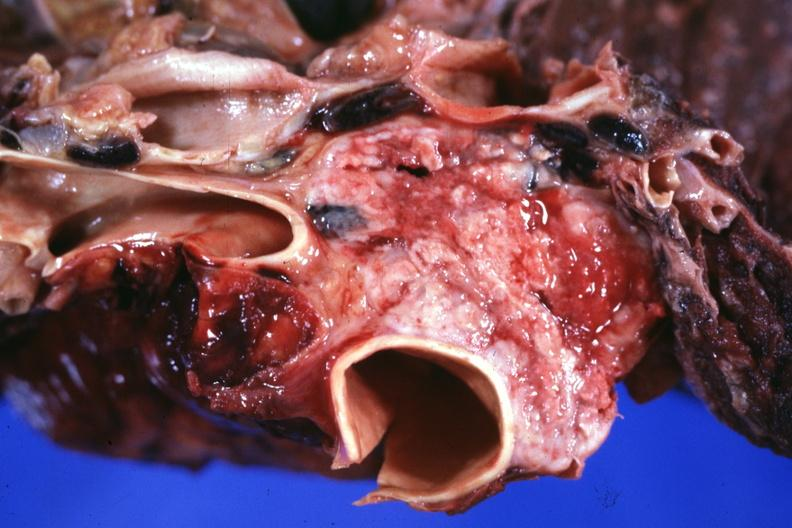s hypertension present?
Answer the question using a single word or phrase. No 